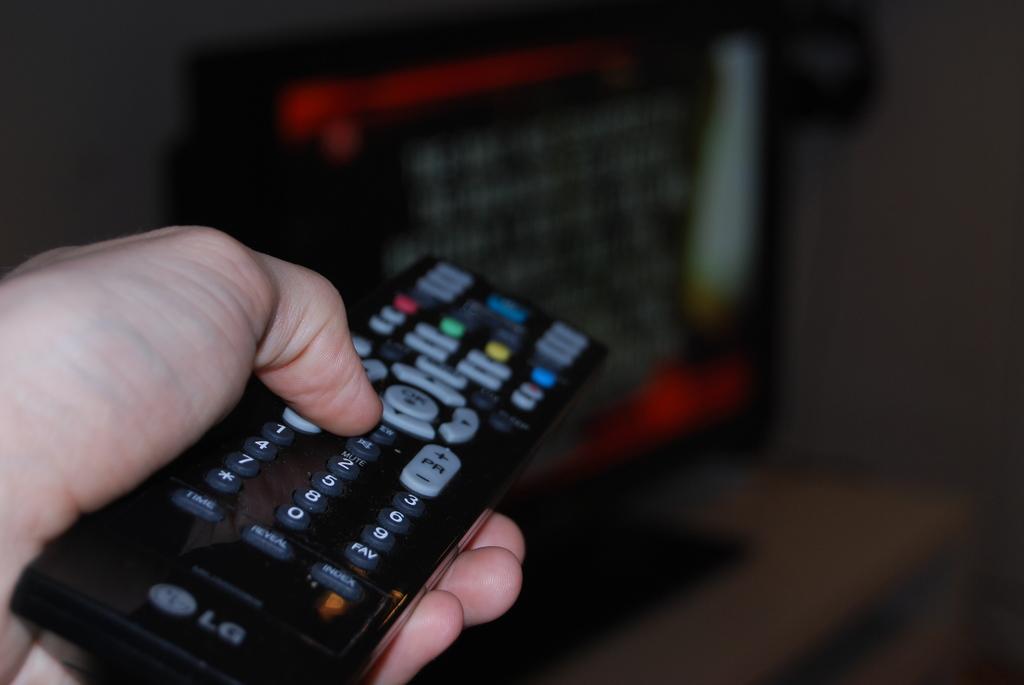Who manufactures the remote control?
Offer a terse response. Lg. Does the remote have a button for the number 7?
Offer a very short reply. Yes. 